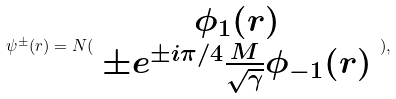<formula> <loc_0><loc_0><loc_500><loc_500>\psi ^ { \pm } ( r ) = N ( \begin{array} { c } \phi _ { 1 } ( r ) \\ \pm e ^ { \pm i \pi / 4 } \frac { M } { \sqrt { \gamma } } \phi _ { - 1 } ( r ) \end{array} ) ,</formula> 